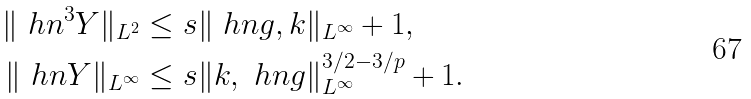<formula> <loc_0><loc_0><loc_500><loc_500>\| \ h n ^ { 3 } Y \| _ { L ^ { 2 } } & \leq s \| \ h n g , k \| _ { L ^ { \infty } } + 1 , \\ \| \ h n Y \| _ { L ^ { \infty } } & \leq s \| k , \ h n g \| _ { L ^ { \infty } } ^ { 3 / 2 - 3 / p } + 1 .</formula> 